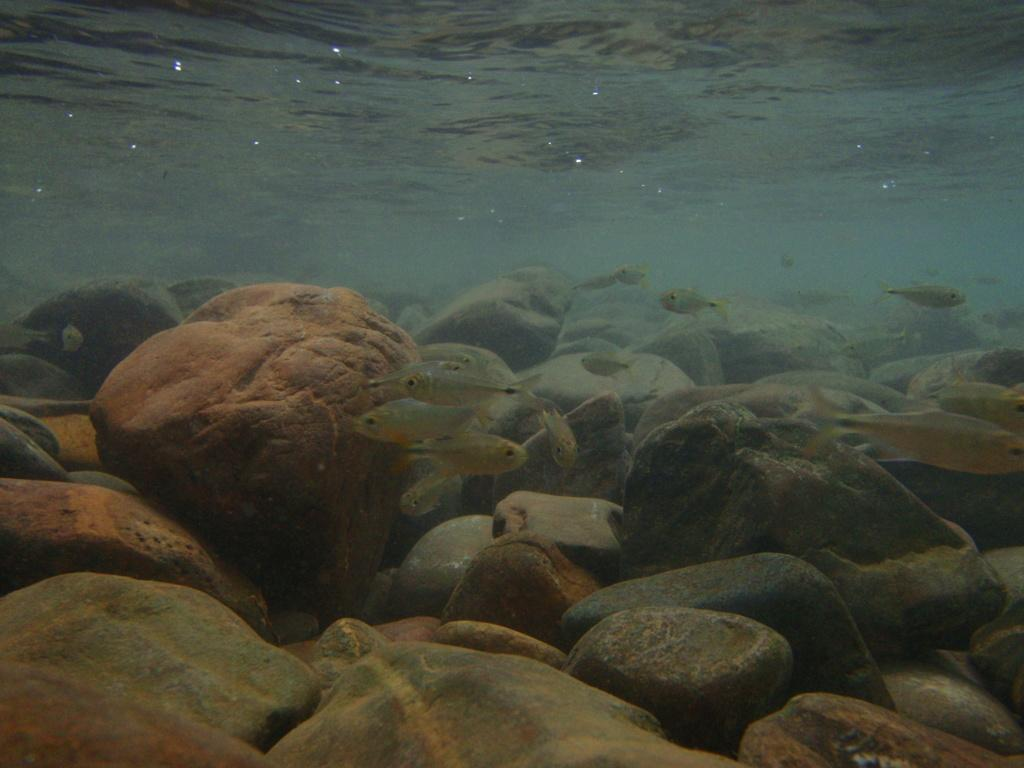What type of animals can be seen in the image? There are fishes under the water in the image. What else can be found under the water in the image? There are stones under the water in the image. What type of brush can be seen in the image? There is no brush present in the image; it features fishes and stones under the water. Are there any shoes visible in the image? There are no shoes present in the image; it features fishes and stones under the water. 